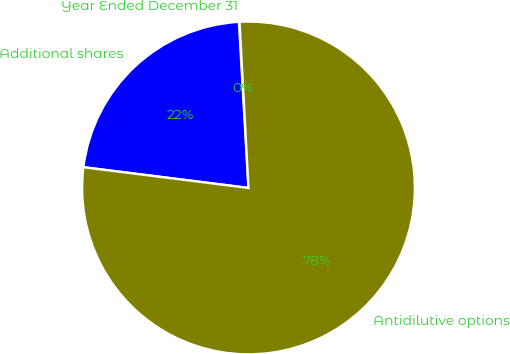Convert chart to OTSL. <chart><loc_0><loc_0><loc_500><loc_500><pie_chart><fcel>Year Ended December 31<fcel>Additional shares<fcel>Antidilutive options<nl><fcel>0.06%<fcel>22.09%<fcel>77.84%<nl></chart> 